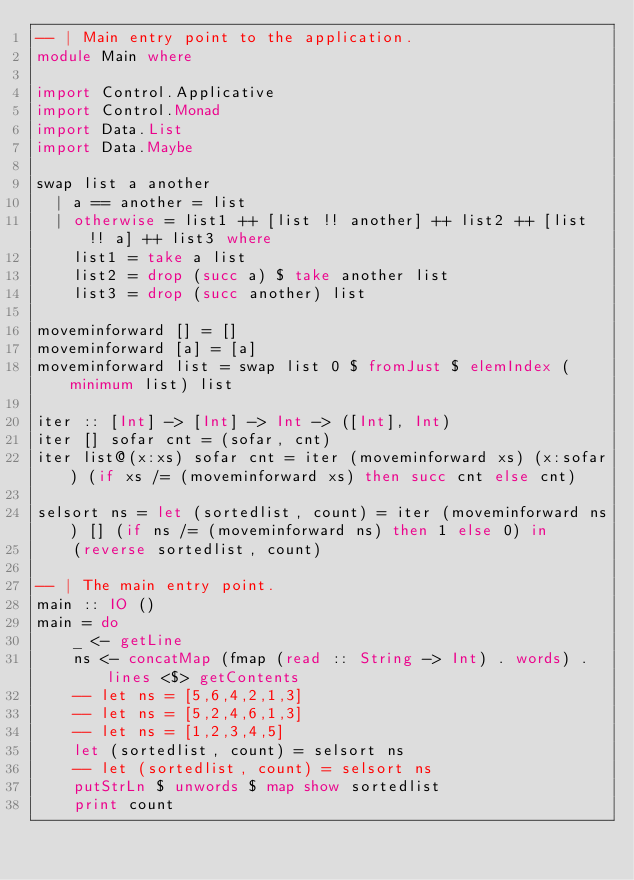Convert code to text. <code><loc_0><loc_0><loc_500><loc_500><_Haskell_>-- | Main entry point to the application.
module Main where
 
import Control.Applicative
import Control.Monad
import Data.List
import Data.Maybe

swap list a another
  | a == another = list
  | otherwise = list1 ++ [list !! another] ++ list2 ++ [list !! a] ++ list3 where
    list1 = take a list
    list2 = drop (succ a) $ take another list
    list3 = drop (succ another) list

moveminforward [] = []
moveminforward [a] = [a]
moveminforward list = swap list 0 $ fromJust $ elemIndex (minimum list) list

iter :: [Int] -> [Int] -> Int -> ([Int], Int)
iter [] sofar cnt = (sofar, cnt)
iter list@(x:xs) sofar cnt = iter (moveminforward xs) (x:sofar) (if xs /= (moveminforward xs) then succ cnt else cnt)

selsort ns = let (sortedlist, count) = iter (moveminforward ns) [] (if ns /= (moveminforward ns) then 1 else 0) in
    (reverse sortedlist, count)

-- | The main entry point.
main :: IO ()
main = do
    _ <- getLine
    ns <- concatMap (fmap (read :: String -> Int) . words) . lines <$> getContents
    -- let ns = [5,6,4,2,1,3]
    -- let ns = [5,2,4,6,1,3]
    -- let ns = [1,2,3,4,5]
    let (sortedlist, count) = selsort ns
    -- let (sortedlist, count) = selsort ns
    putStrLn $ unwords $ map show sortedlist
    print count</code> 